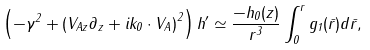Convert formula to latex. <formula><loc_0><loc_0><loc_500><loc_500>\left ( - \gamma ^ { 2 } + \left ( V _ { A z } \partial _ { z } + i k _ { 0 } \cdot V _ { A } \right ) ^ { 2 } \right ) h ^ { \prime } \simeq \frac { - h _ { 0 } ( z ) } { r ^ { 3 } } \int _ { 0 } ^ { r } g _ { 1 } ( \bar { r } ) d \bar { r } ,</formula> 